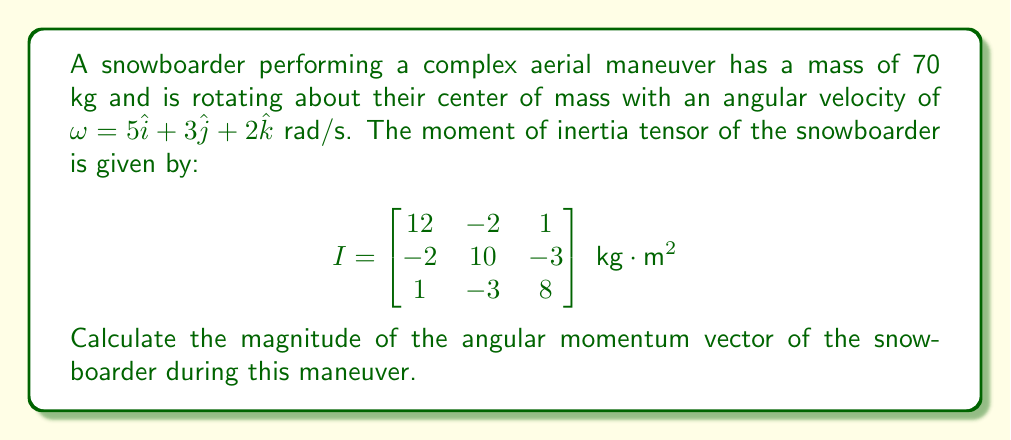Help me with this question. To solve this problem, we'll follow these steps:

1) The angular momentum vector $\mathbf{L}$ is given by the product of the moment of inertia tensor $I$ and the angular velocity vector $\mathbf{\omega}$:

   $\mathbf{L} = I\mathbf{\omega}$

2) We need to perform matrix multiplication:

   $$\mathbf{L} = \begin{bmatrix}
   12 & -2 & 1 \\
   -2 & 10 & -3 \\
   1 & -3 & 8
   \end{bmatrix} \begin{bmatrix}
   5 \\
   3 \\
   2
   \end{bmatrix}$$

3) Multiplying the matrix and vector:

   $$\mathbf{L} = \begin{bmatrix}
   (12 \cdot 5) + (-2 \cdot 3) + (1 \cdot 2) \\
   (-2 \cdot 5) + (10 \cdot 3) + (-3 \cdot 2) \\
   (1 \cdot 5) + (-3 \cdot 3) + (8 \cdot 2)
   \end{bmatrix}$$

4) Simplifying:

   $$\mathbf{L} = \begin{bmatrix}
   60 - 6 + 2 \\
   -10 + 30 - 6 \\
   5 - 9 + 16
   \end{bmatrix} = \begin{bmatrix}
   56 \\
   14 \\
   12
   \end{bmatrix} \text{ kg}\cdot\text{m}^2/\text{s}$$

5) To find the magnitude of this vector, we use the Euclidean norm:

   $|\mathbf{L}| = \sqrt{L_x^2 + L_y^2 + L_z^2}$

6) Substituting the values:

   $|\mathbf{L}| = \sqrt{56^2 + 14^2 + 12^2}$

7) Calculating:

   $|\mathbf{L}| = \sqrt{3136 + 196 + 144} = \sqrt{3476} \approx 58.96 \text{ kg}\cdot\text{m}^2/\text{s}$
Answer: $58.96 \text{ kg}\cdot\text{m}^2/\text{s}$ 